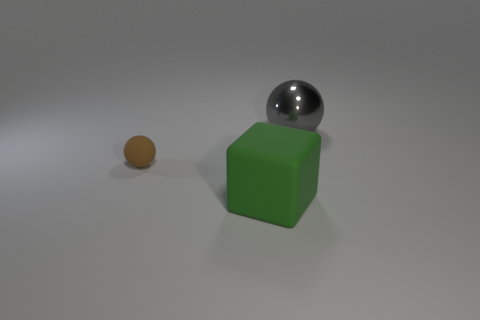How many gray things are the same size as the green thing?
Keep it short and to the point. 1. There is a object that is to the right of the tiny matte thing and left of the large metal object; what is it made of?
Make the answer very short. Rubber. There is a cube that is the same size as the metallic ball; what is its material?
Your answer should be compact. Rubber. How big is the sphere that is to the right of the large thing that is left of the object that is right of the large rubber object?
Ensure brevity in your answer.  Large. The ball that is made of the same material as the big block is what size?
Ensure brevity in your answer.  Small. Do the green rubber cube and the sphere in front of the shiny object have the same size?
Ensure brevity in your answer.  No. What is the shape of the object behind the small brown ball?
Give a very brief answer. Sphere. There is a thing to the left of the green matte object that is in front of the tiny brown thing; is there a large metallic sphere that is in front of it?
Provide a short and direct response. No. There is another object that is the same shape as the big gray metal thing; what is it made of?
Offer a very short reply. Rubber. Is there anything else that is made of the same material as the gray thing?
Provide a short and direct response. No. 